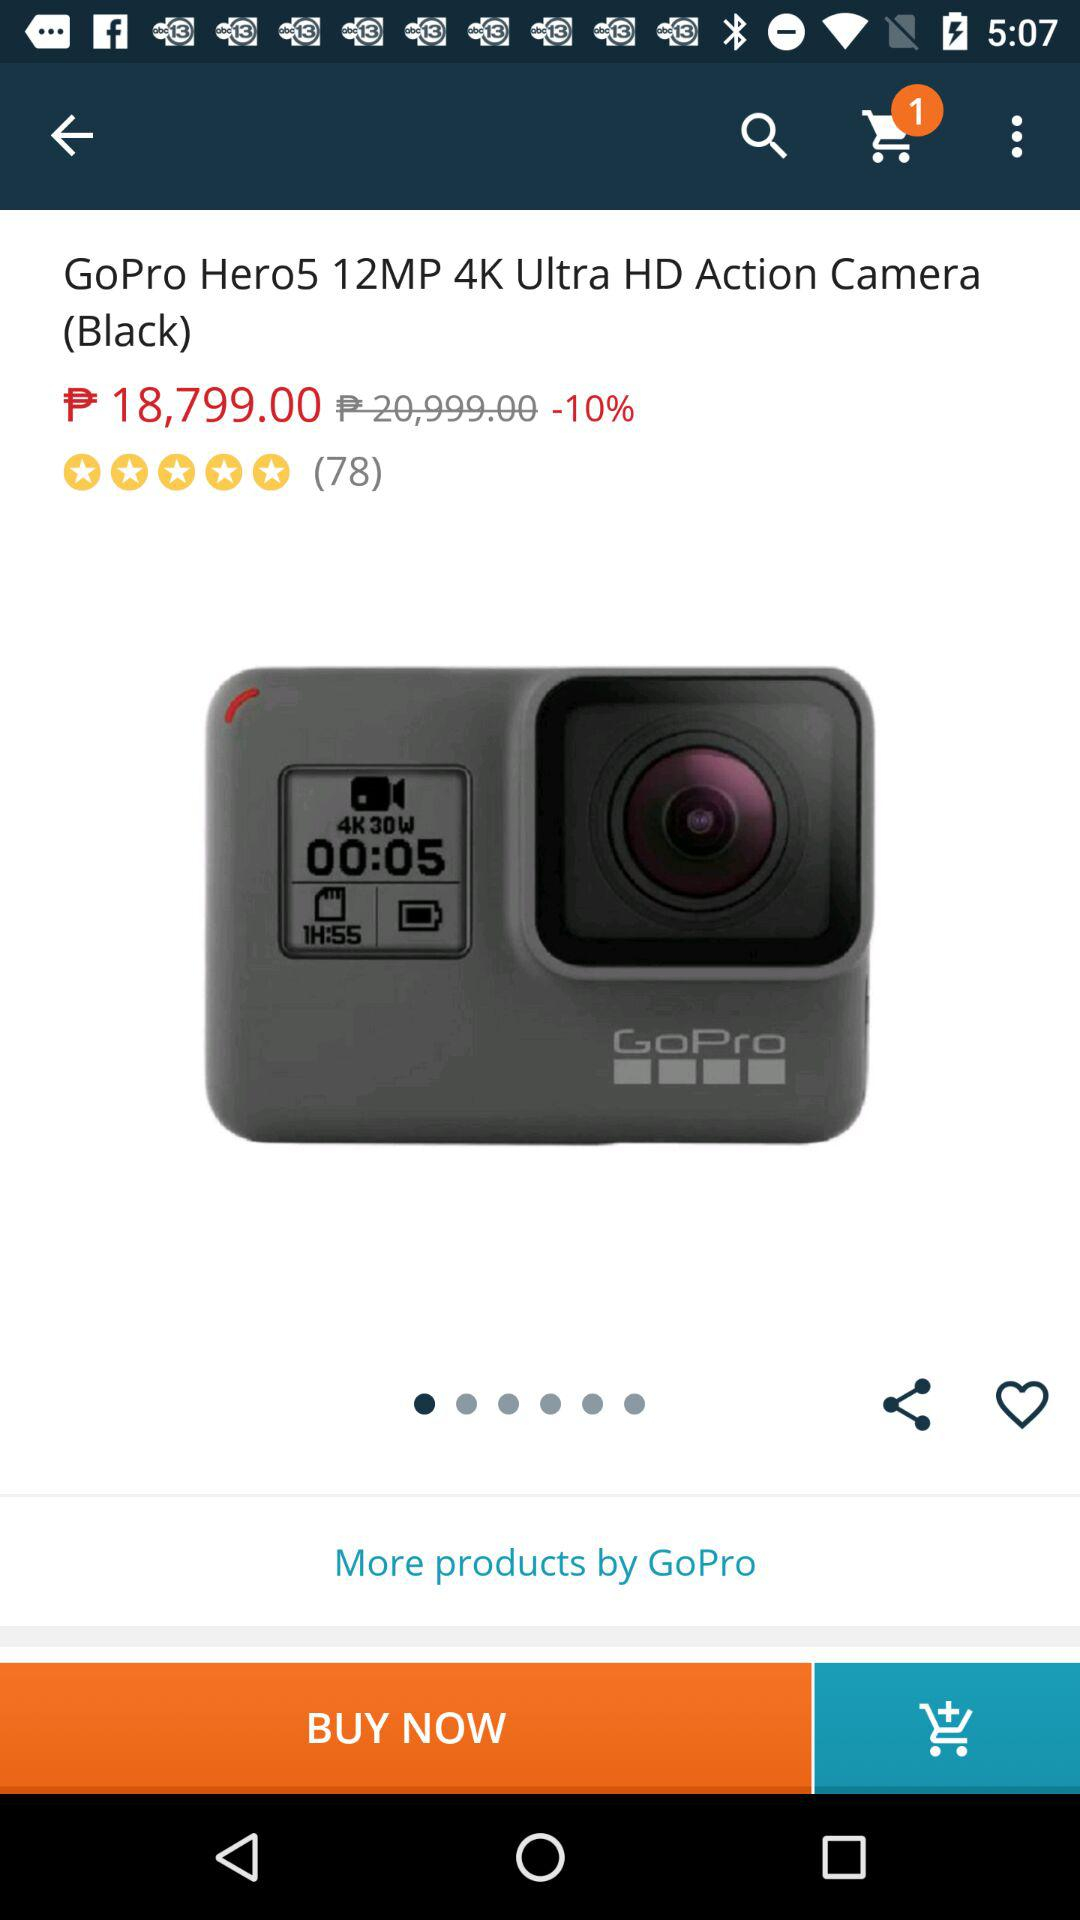How much is the discount on the product?
Answer the question using a single word or phrase. 10% 